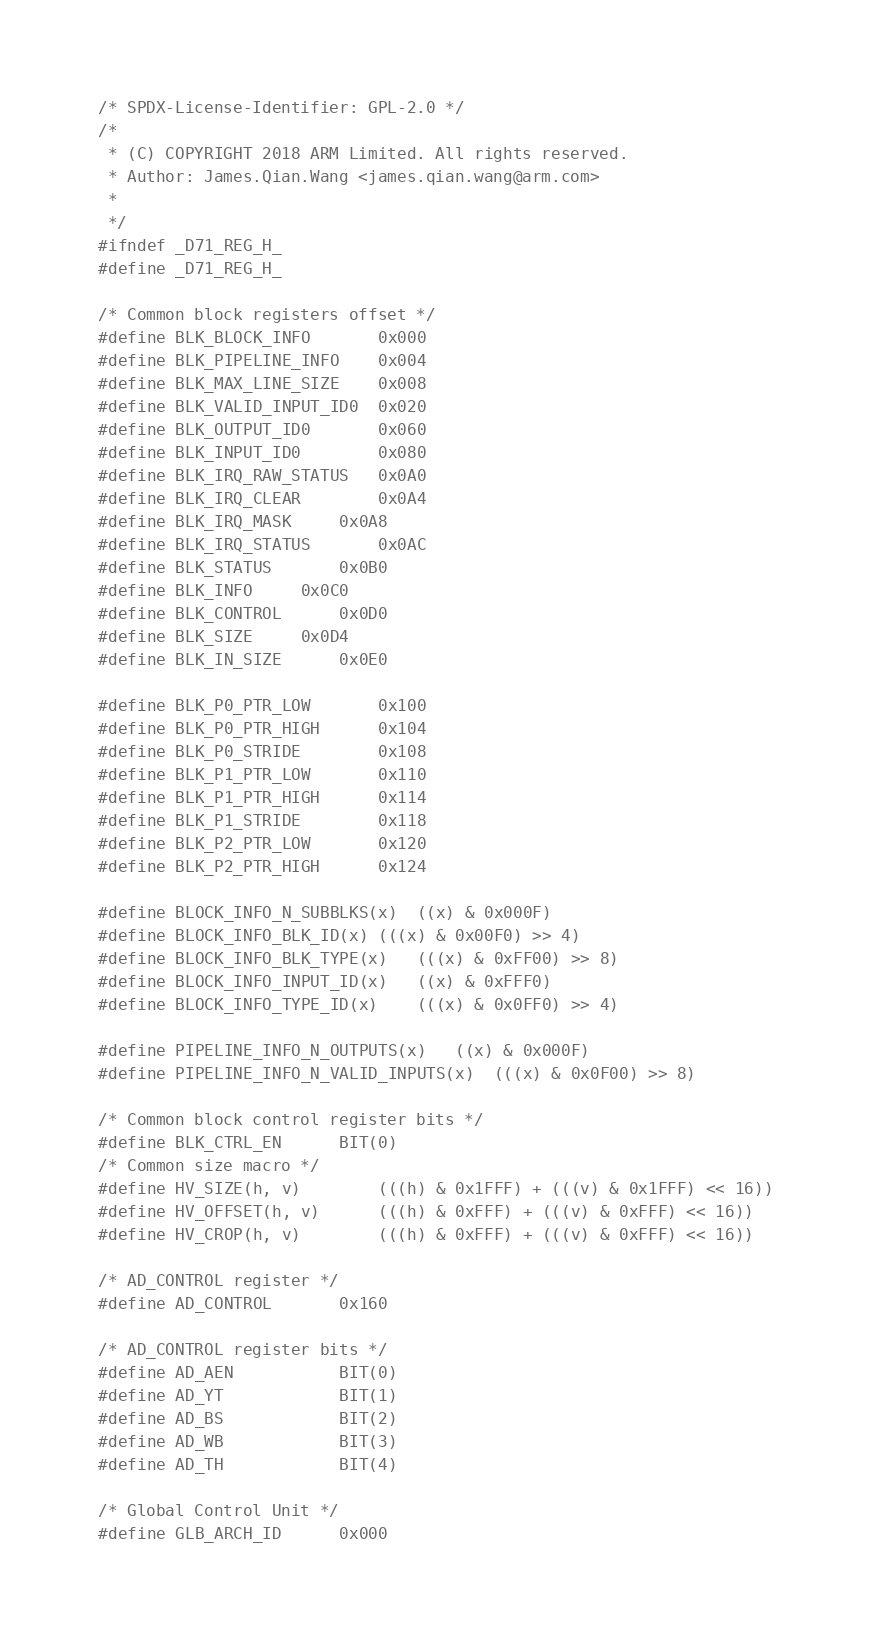Convert code to text. <code><loc_0><loc_0><loc_500><loc_500><_C_>/* SPDX-License-Identifier: GPL-2.0 */
/*
 * (C) COPYRIGHT 2018 ARM Limited. All rights reserved.
 * Author: James.Qian.Wang <james.qian.wang@arm.com>
 *
 */
#ifndef _D71_REG_H_
#define _D71_REG_H_

/* Common block registers offset */
#define BLK_BLOCK_INFO		0x000
#define BLK_PIPELINE_INFO	0x004
#define BLK_MAX_LINE_SIZE	0x008
#define BLK_VALID_INPUT_ID0	0x020
#define BLK_OUTPUT_ID0		0x060
#define BLK_INPUT_ID0		0x080
#define BLK_IRQ_RAW_STATUS	0x0A0
#define BLK_IRQ_CLEAR		0x0A4
#define BLK_IRQ_MASK		0x0A8
#define BLK_IRQ_STATUS		0x0AC
#define BLK_STATUS		0x0B0
#define BLK_INFO		0x0C0
#define BLK_CONTROL		0x0D0
#define BLK_SIZE		0x0D4
#define BLK_IN_SIZE		0x0E0

#define BLK_P0_PTR_LOW		0x100
#define BLK_P0_PTR_HIGH		0x104
#define BLK_P0_STRIDE		0x108
#define BLK_P1_PTR_LOW		0x110
#define BLK_P1_PTR_HIGH		0x114
#define BLK_P1_STRIDE		0x118
#define BLK_P2_PTR_LOW		0x120
#define BLK_P2_PTR_HIGH		0x124

#define BLOCK_INFO_N_SUBBLKS(x)	((x) & 0x000F)
#define BLOCK_INFO_BLK_ID(x)	(((x) & 0x00F0) >> 4)
#define BLOCK_INFO_BLK_TYPE(x)	(((x) & 0xFF00) >> 8)
#define BLOCK_INFO_INPUT_ID(x)	((x) & 0xFFF0)
#define BLOCK_INFO_TYPE_ID(x)	(((x) & 0x0FF0) >> 4)

#define PIPELINE_INFO_N_OUTPUTS(x)	((x) & 0x000F)
#define PIPELINE_INFO_N_VALID_INPUTS(x)	(((x) & 0x0F00) >> 8)

/* Common block control register bits */
#define BLK_CTRL_EN		BIT(0)
/* Common size macro */
#define HV_SIZE(h, v)		(((h) & 0x1FFF) + (((v) & 0x1FFF) << 16))
#define HV_OFFSET(h, v)		(((h) & 0xFFF) + (((v) & 0xFFF) << 16))
#define HV_CROP(h, v)		(((h) & 0xFFF) + (((v) & 0xFFF) << 16))

/* AD_CONTROL register */
#define AD_CONTROL		0x160

/* AD_CONTROL register bits */
#define AD_AEN			BIT(0)
#define AD_YT			BIT(1)
#define AD_BS			BIT(2)
#define AD_WB			BIT(3)
#define AD_TH			BIT(4)

/* Global Control Unit */
#define GLB_ARCH_ID		0x000</code> 